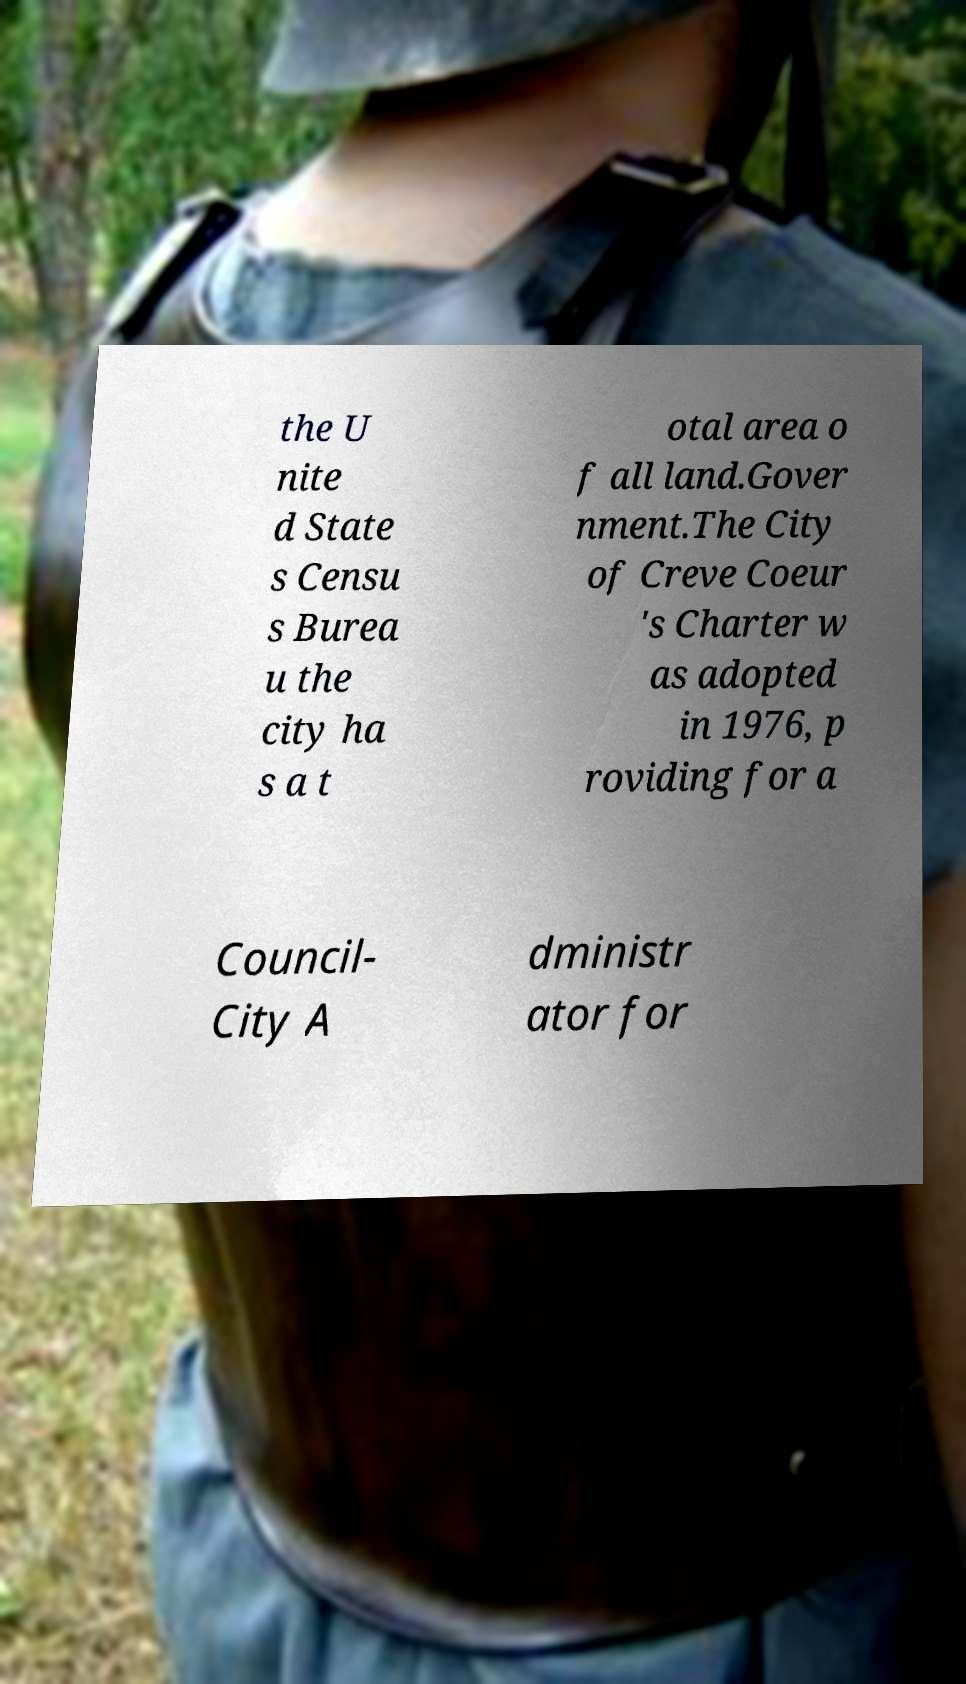Please read and relay the text visible in this image. What does it say? the U nite d State s Censu s Burea u the city ha s a t otal area o f all land.Gover nment.The City of Creve Coeur 's Charter w as adopted in 1976, p roviding for a Council- City A dministr ator for 